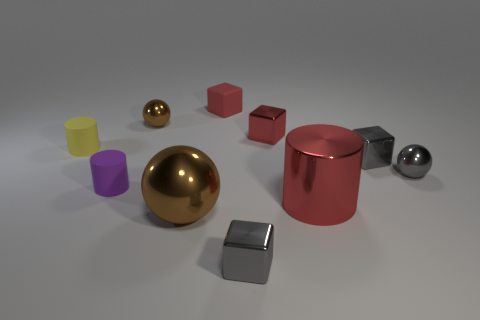Subtract 1 blocks. How many blocks are left? 3 Subtract all cylinders. How many objects are left? 7 Add 6 red matte blocks. How many red matte blocks are left? 7 Add 2 red matte cubes. How many red matte cubes exist? 3 Subtract 0 blue cylinders. How many objects are left? 10 Subtract all tiny brown metallic blocks. Subtract all small spheres. How many objects are left? 8 